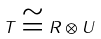Convert formula to latex. <formula><loc_0><loc_0><loc_500><loc_500>T \cong R \otimes U</formula> 